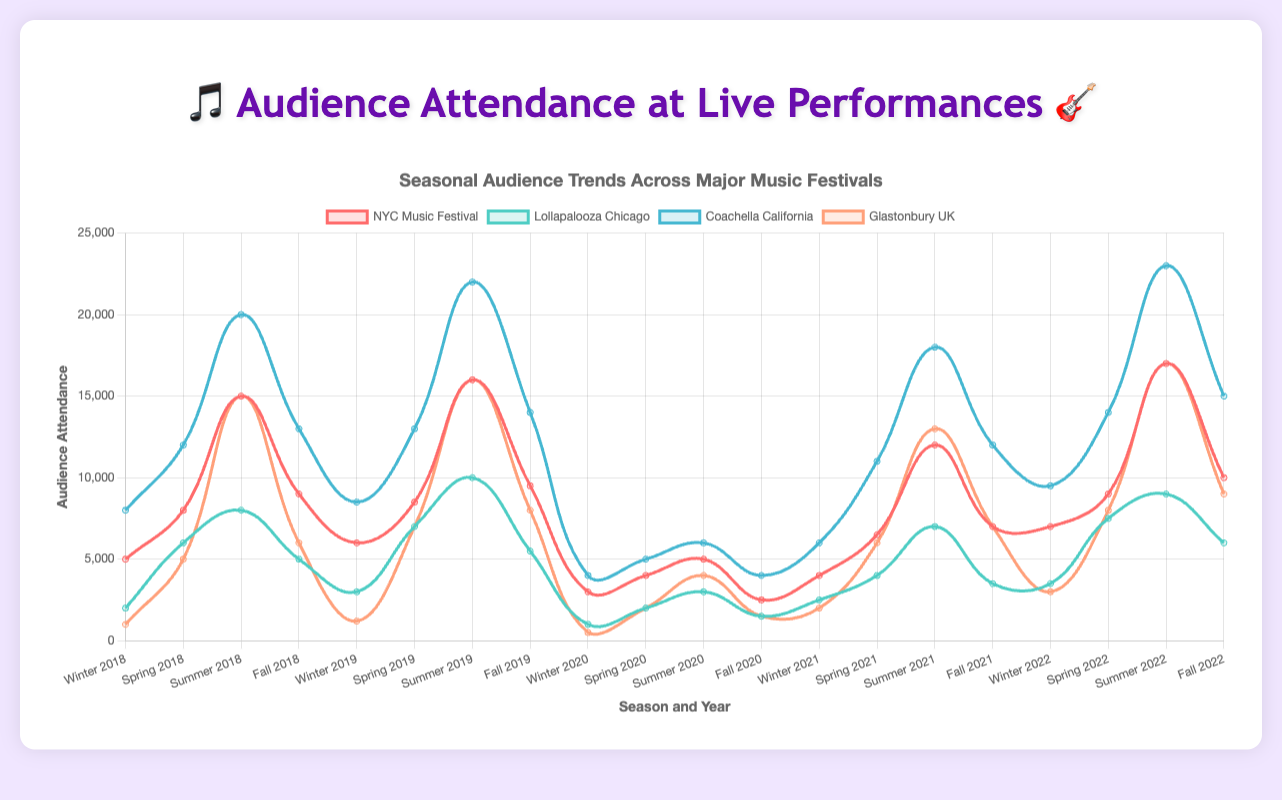What year saw the lowest attendance for Coachella California during the Summer season? Look at the line corresponding to Coachella California, note the lowest point during the Summer season. The lowest attendance in Summer for Coachella California occurred in 2020 with 6000 attendees.
Answer: 2020 Which festival had the highest attendance in Winter 2022? Examine the lines for all festivals and identify the highest point for Winter 2022. Coachella California had the highest attendance in Winter 2022 with 9500 attendees.
Answer: Coachella California What is the average attendance for Lollapalooza Chicago during the Winter season across all years? Add the attendance figures for Winter season from 2018 to 2022 and divide by 5: (2000 + 3000 + 1000 + 2500 + 3500)/5 = 2400.
Answer: 2400 Between 2019 and 2021, how much did the Fall season attendance for NYC Music Festival change? Find the difference in attendance between Fall 2021 and Fall 2019 for NYC Music Festival: 7000 (2021) - 9500 (2019) = -2500.
Answer: -2500 Which season saw the highest attendance for Glastonbury UK in 2019, and what was the attendance number? Check the data points for Glastonbury UK in 2019 and identify the highest attendance across the seasons. Summer had the highest attendance with 16000.
Answer: Summer 16000 What is the total attendance for Coachella California in 2021 across all seasons? Sum the attendance figures for Coachella California in 2021 for all seasons: 6000 + 11000 + 18000 + 12000 = 47000.
Answer: 47000 In which season did the attendance for NYC Music Festival drop the most from 2019 to 2020? Calculate the difference in attendance for each season from 2019 to 2020 for NYC Music Festival and find the largest drop. The biggest drop was in Summer: 16000 (2019) - 5000 (2020) = 11000.
Answer: Summer Which festival experienced the smallest attendance in Fall 2020, and what was the attendance number? Look at the Fall 2020 attendance and identify the lowest point among the festivals. The smallest attendance was at Lollapalooza Chicago with 1500 attendees.
Answer: Lollapalooza Chicago 1500 Compare the Spring attendance for Coachella California in 2021 to that in 2022. What is the percentage increase? Calculate the increase in attendance and its percentage: (14000 - 11000) / 11000 * 100 = 27.27%.
Answer: 27.27% Between Lollapalooza Chicago and Glastonbury UK, which festival had a higher average attendance across all seasons in 2022? Calculate the average attendance for each festival in 2022 and compare: 
Lollapalooza: (3500 + 7500 + 9000 + 6000) / 4 = 6750; Glastonbury: (3000 + 8000 + 17000 + 9000) / 4 = 9250. Glastonbury UK had the higher average attendance.
Answer: Glastonbury UK 